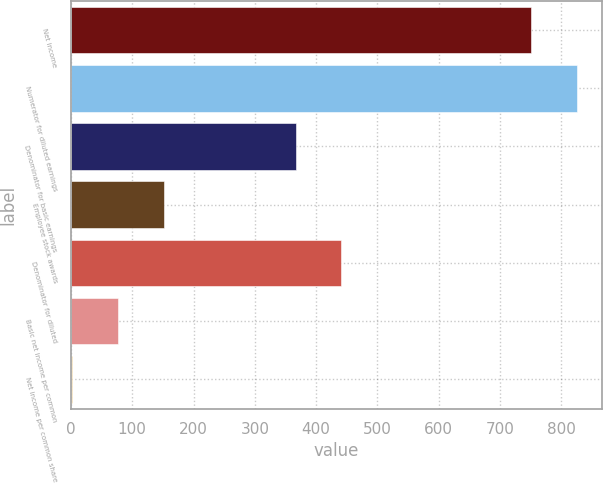Convert chart. <chart><loc_0><loc_0><loc_500><loc_500><bar_chart><fcel>Net income<fcel>Numerator for diluted earnings<fcel>Denominator for basic earnings<fcel>Employee stock awards<fcel>Denominator for diluted<fcel>Basic net income per common<fcel>Net income per common share<nl><fcel>750.7<fcel>825.57<fcel>366.3<fcel>151.77<fcel>441.17<fcel>76.9<fcel>2.03<nl></chart> 